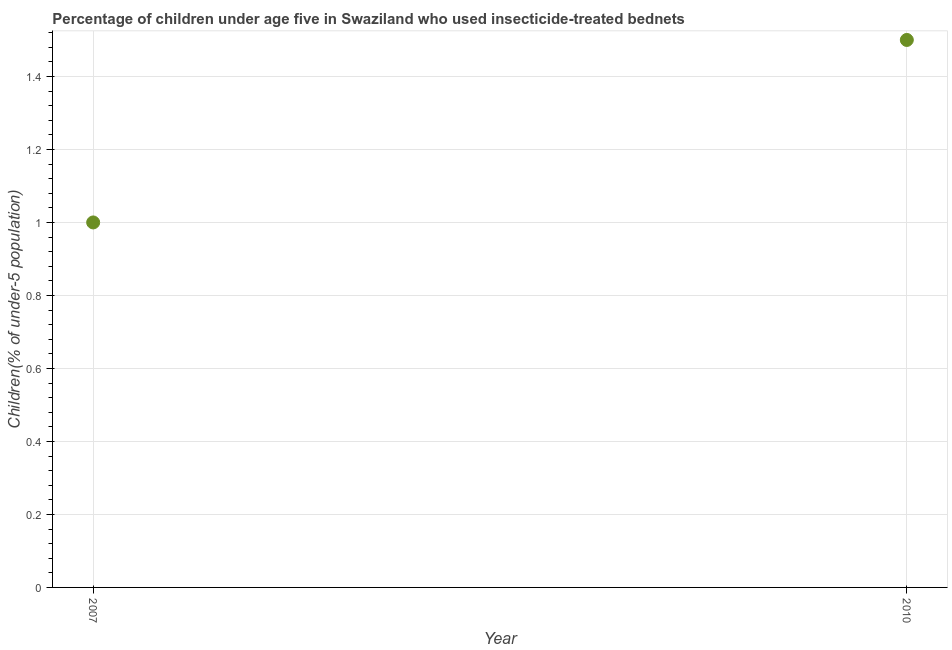Across all years, what is the maximum percentage of children who use of insecticide-treated bed nets?
Provide a short and direct response. 1.5. In which year was the percentage of children who use of insecticide-treated bed nets maximum?
Your answer should be very brief. 2010. What is the average percentage of children who use of insecticide-treated bed nets per year?
Offer a terse response. 1.25. What is the median percentage of children who use of insecticide-treated bed nets?
Your answer should be compact. 1.25. In how many years, is the percentage of children who use of insecticide-treated bed nets greater than 1.12 %?
Offer a very short reply. 1. What is the ratio of the percentage of children who use of insecticide-treated bed nets in 2007 to that in 2010?
Your answer should be compact. 0.67. In how many years, is the percentage of children who use of insecticide-treated bed nets greater than the average percentage of children who use of insecticide-treated bed nets taken over all years?
Your answer should be very brief. 1. How many years are there in the graph?
Your answer should be compact. 2. Are the values on the major ticks of Y-axis written in scientific E-notation?
Your answer should be compact. No. Does the graph contain any zero values?
Provide a short and direct response. No. What is the title of the graph?
Ensure brevity in your answer.  Percentage of children under age five in Swaziland who used insecticide-treated bednets. What is the label or title of the Y-axis?
Offer a very short reply. Children(% of under-5 population). What is the difference between the Children(% of under-5 population) in 2007 and 2010?
Provide a short and direct response. -0.5. What is the ratio of the Children(% of under-5 population) in 2007 to that in 2010?
Your answer should be very brief. 0.67. 